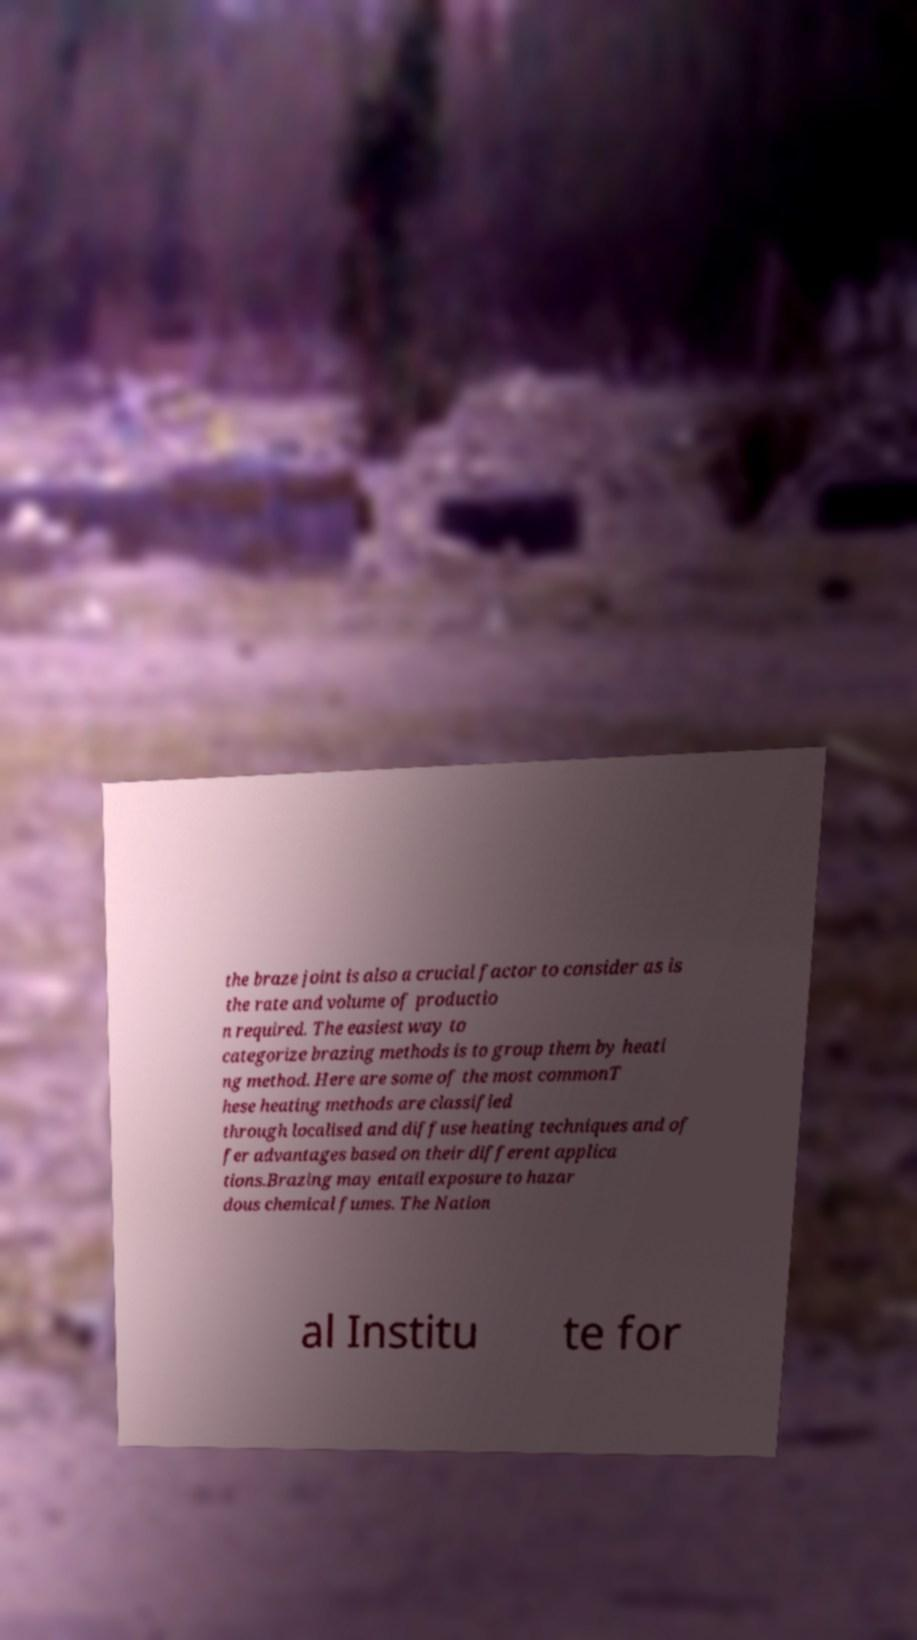Can you read and provide the text displayed in the image?This photo seems to have some interesting text. Can you extract and type it out for me? the braze joint is also a crucial factor to consider as is the rate and volume of productio n required. The easiest way to categorize brazing methods is to group them by heati ng method. Here are some of the most commonT hese heating methods are classified through localised and diffuse heating techniques and of fer advantages based on their different applica tions.Brazing may entail exposure to hazar dous chemical fumes. The Nation al Institu te for 